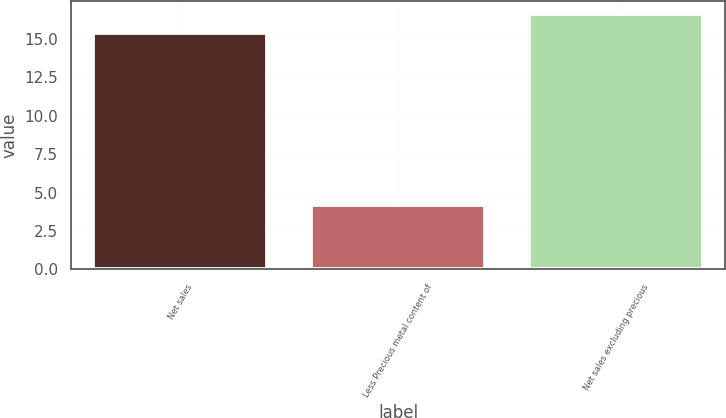<chart> <loc_0><loc_0><loc_500><loc_500><bar_chart><fcel>Net sales<fcel>Less Precious metal content of<fcel>Net sales excluding precious<nl><fcel>15.4<fcel>4.2<fcel>16.62<nl></chart> 